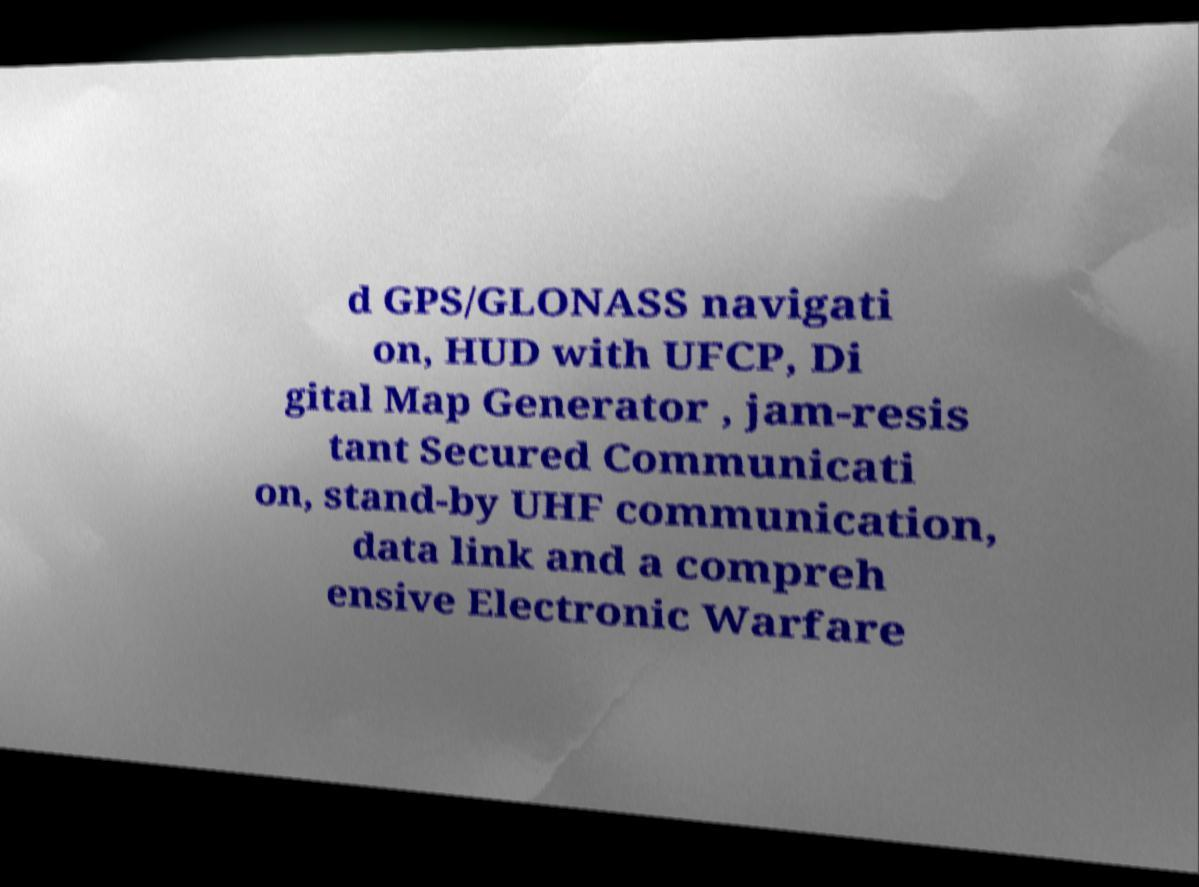Can you accurately transcribe the text from the provided image for me? d GPS/GLONASS navigati on, HUD with UFCP, Di gital Map Generator , jam-resis tant Secured Communicati on, stand-by UHF communication, data link and a compreh ensive Electronic Warfare 